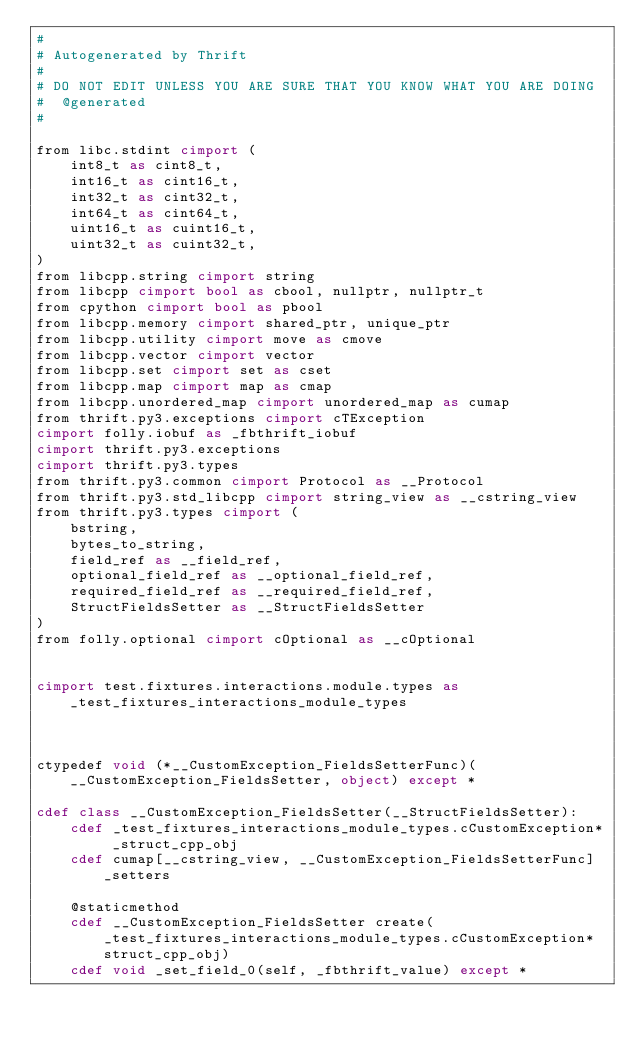Convert code to text. <code><loc_0><loc_0><loc_500><loc_500><_Cython_>#
# Autogenerated by Thrift
#
# DO NOT EDIT UNLESS YOU ARE SURE THAT YOU KNOW WHAT YOU ARE DOING
#  @generated
#

from libc.stdint cimport (
    int8_t as cint8_t,
    int16_t as cint16_t,
    int32_t as cint32_t,
    int64_t as cint64_t,
    uint16_t as cuint16_t,
    uint32_t as cuint32_t,
)
from libcpp.string cimport string
from libcpp cimport bool as cbool, nullptr, nullptr_t
from cpython cimport bool as pbool
from libcpp.memory cimport shared_ptr, unique_ptr
from libcpp.utility cimport move as cmove
from libcpp.vector cimport vector
from libcpp.set cimport set as cset
from libcpp.map cimport map as cmap
from libcpp.unordered_map cimport unordered_map as cumap
from thrift.py3.exceptions cimport cTException
cimport folly.iobuf as _fbthrift_iobuf
cimport thrift.py3.exceptions
cimport thrift.py3.types
from thrift.py3.common cimport Protocol as __Protocol
from thrift.py3.std_libcpp cimport string_view as __cstring_view
from thrift.py3.types cimport (
    bstring,
    bytes_to_string,
    field_ref as __field_ref,
    optional_field_ref as __optional_field_ref,
    required_field_ref as __required_field_ref,
    StructFieldsSetter as __StructFieldsSetter
)
from folly.optional cimport cOptional as __cOptional


cimport test.fixtures.interactions.module.types as _test_fixtures_interactions_module_types



ctypedef void (*__CustomException_FieldsSetterFunc)(__CustomException_FieldsSetter, object) except *

cdef class __CustomException_FieldsSetter(__StructFieldsSetter):
    cdef _test_fixtures_interactions_module_types.cCustomException* _struct_cpp_obj
    cdef cumap[__cstring_view, __CustomException_FieldsSetterFunc] _setters

    @staticmethod
    cdef __CustomException_FieldsSetter create(_test_fixtures_interactions_module_types.cCustomException* struct_cpp_obj)
    cdef void _set_field_0(self, _fbthrift_value) except *

</code> 